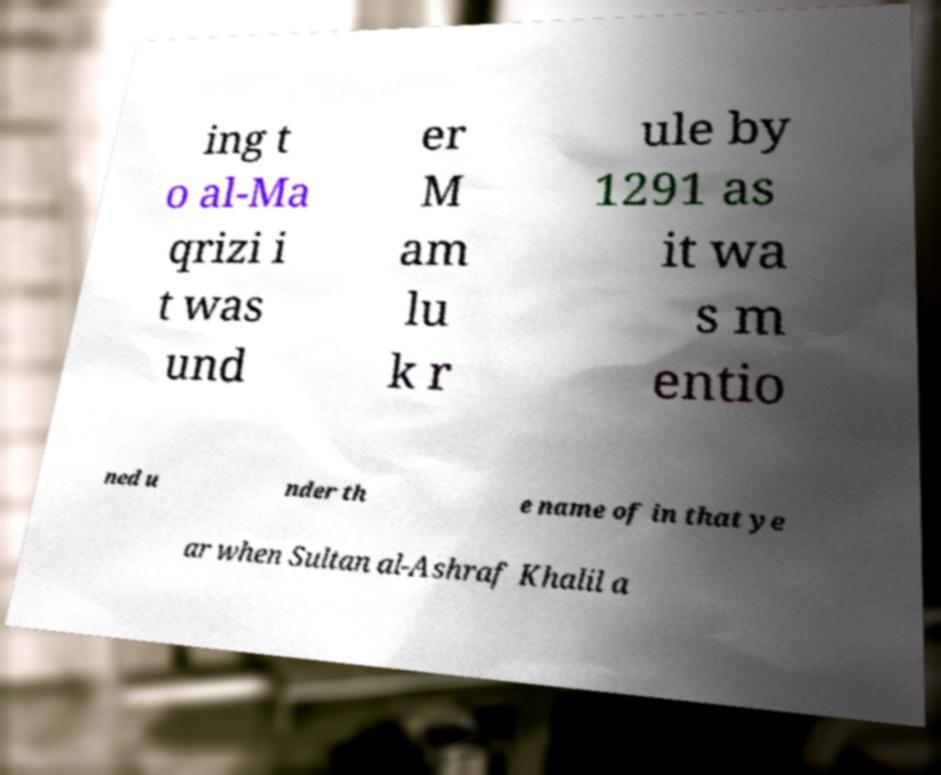Could you assist in decoding the text presented in this image and type it out clearly? ing t o al-Ma qrizi i t was und er M am lu k r ule by 1291 as it wa s m entio ned u nder th e name of in that ye ar when Sultan al-Ashraf Khalil a 